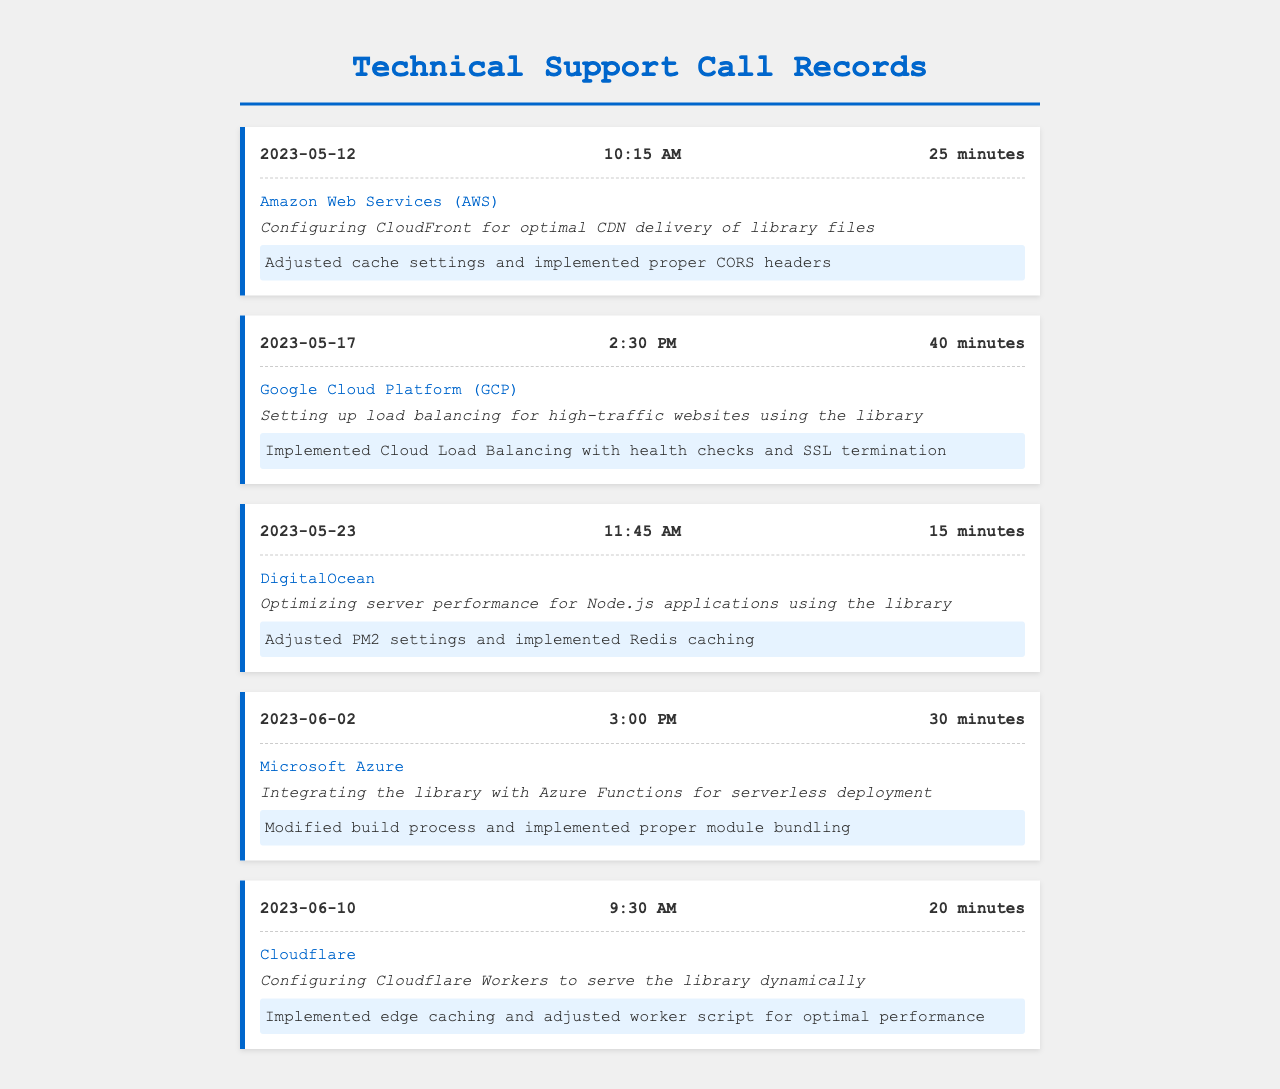What is the date of the call with AWS? The call with AWS took place on May 12, 2023.
Answer: May 12, 2023 How long was the call with Google Cloud Platform? The duration of the call with Google Cloud Platform was 40 minutes.
Answer: 40 minutes What was the issue discussed during the call with DigitalOcean? The issue discussed was optimizing server performance for Node.js applications using the library.
Answer: Optimizing server performance for Node.js applications using the library What type of support was provided for the Azure Functions integration? The support provided involved modifying the build process and implementing proper module bundling.
Answer: Modifying build process and implementing proper module bundling Which cloud provider was contacted for configuring Cloudflare Workers? The provider contacted for configuring Cloudflare Workers was Cloudflare.
Answer: Cloudflare What is the resolution related to the CDN delivery with AWS? The resolution related to the CDN delivery with AWS was adjusting cache settings and implementing proper CORS headers.
Answer: Adjusted cache settings and implemented proper CORS headers What time did the call with DigitalOcean start? The call with DigitalOcean started at 11:45 AM.
Answer: 11:45 AM Which cloud provider was involved in the call for load balancing? The provider involved in the call for load balancing was Google Cloud Platform.
Answer: Google Cloud Platform How many minutes was the support call with Cloudflare? The support call with Cloudflare lasted 20 minutes.
Answer: 20 minutes 